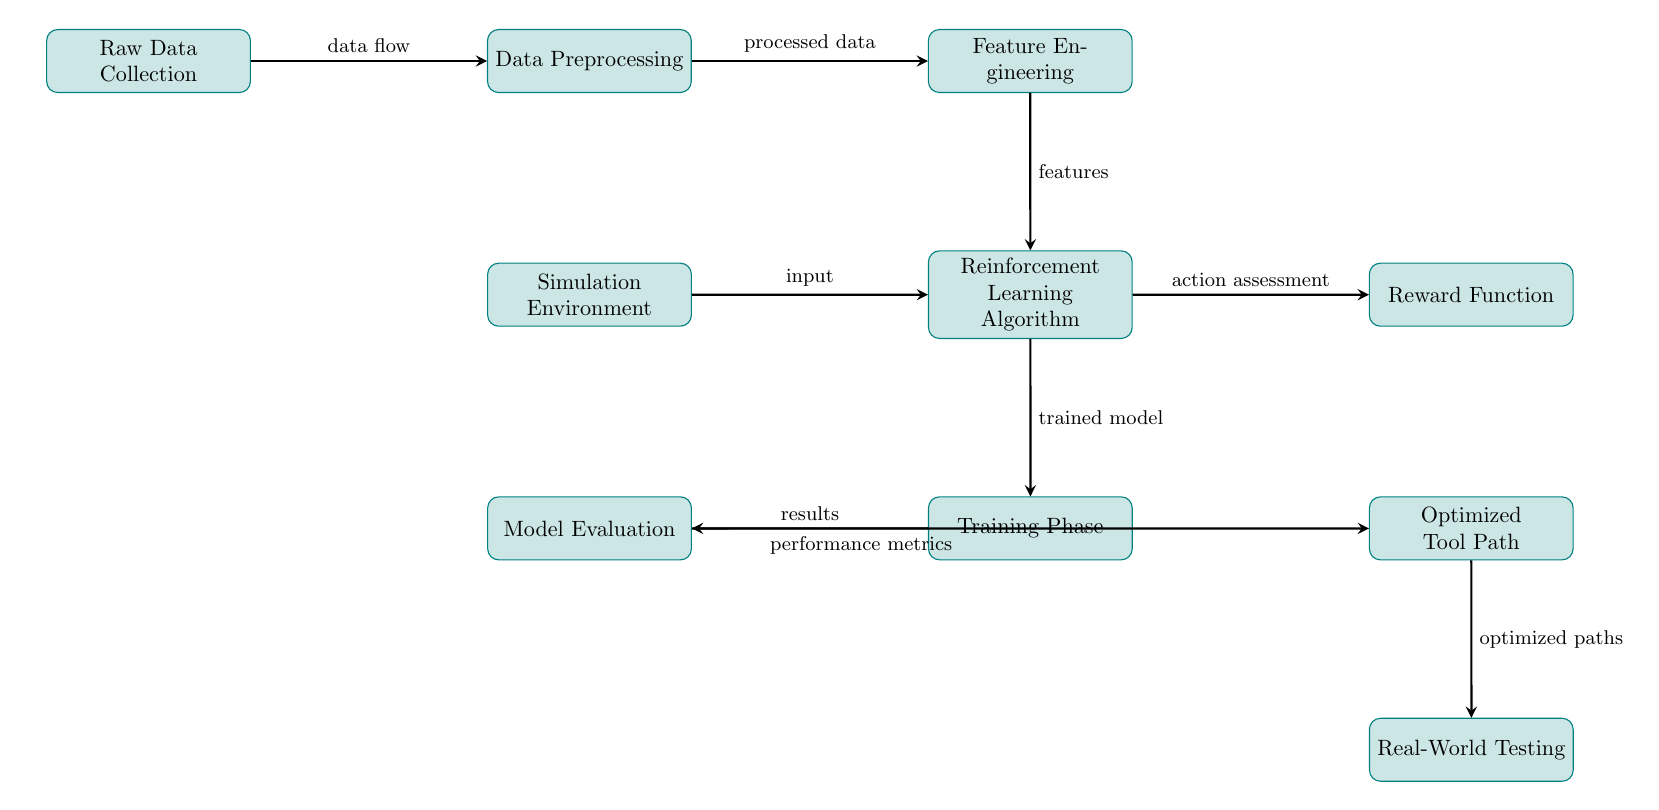What is the first step in the diagram? The first step in the diagram is "Raw Data Collection," which is the initial process before any data manipulation occurs.
Answer: Raw Data Collection How many main processes are shown in the diagram? The diagram shows a total of eight main processes, clearly labeled as distinct steps in the flow of the machine learning approach.
Answer: Eight What flows out of the "Reinforcement Learning Algorithm" node? The "Reinforcement Learning Algorithm" node outputs the "trained model," which indicates the result of the learning process performed using the collected features and inputs.
Answer: Trained model What input does the "Reinforcement Learning Algorithm" receive? The "Reinforcement Learning Algorithm" receives input from the "Simulation Environment," which simulates conditions under which the algorithm learns to optimize tool paths.
Answer: Input What is the connection between "Training Phase" and "Model Evaluation"? The "Training Phase" directly leads to the "Model Evaluation" process, indicating that the results from training are assessed in the evaluation step to understand the performance of the model.
Answer: Results What is the final output of the entire process illustrated in the diagram? The final output of the process is the "Optimized Tool Path," which represents the end goal of the machine learning methods applied throughout the diagram.
Answer: Optimized Tool Path How do "Reward Function" and "Reinforcement Learning Algorithm" interact in the diagram? The "Reward Function" is connected to the "Reinforcement Learning Algorithm," serving to assess actions taken by the algorithm and guide it towards achieving optimal tool paths based on the rewards given.
Answer: Action assessment What is necessary for "Feature Engineering" to take place? "Feature Engineering" requires processed data as its input, which comes from the "Data Preprocessing" step in the diagram.
Answer: Processed data 